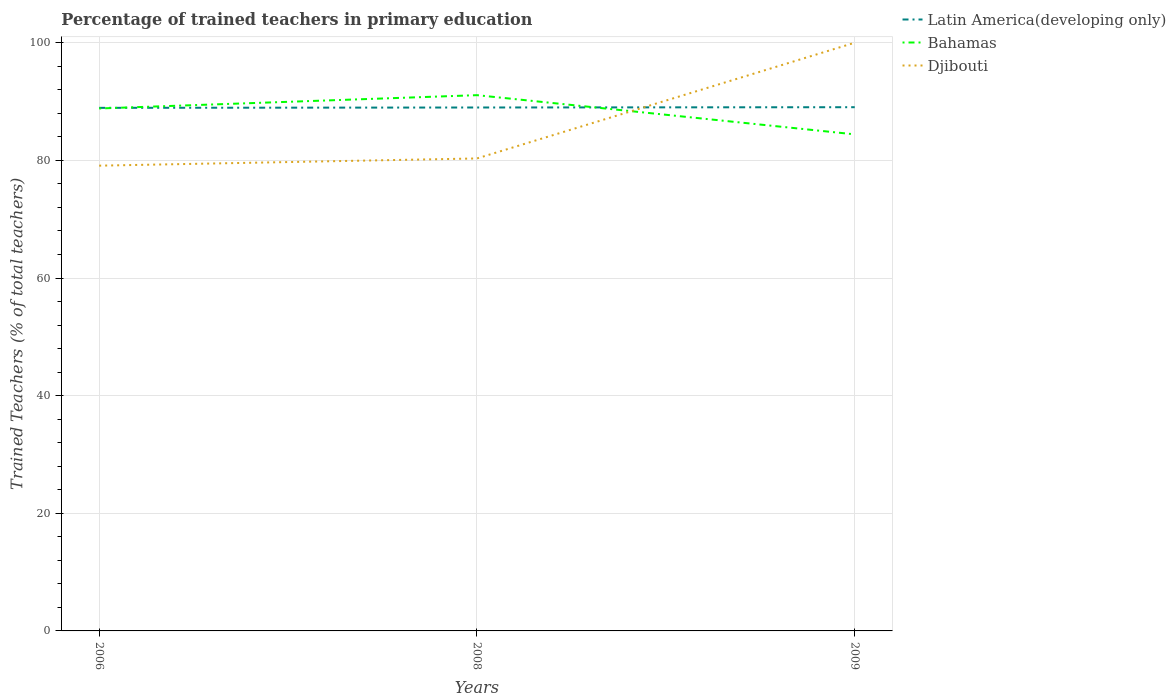How many different coloured lines are there?
Give a very brief answer. 3. Does the line corresponding to Djibouti intersect with the line corresponding to Latin America(developing only)?
Your answer should be very brief. Yes. Across all years, what is the maximum percentage of trained teachers in Latin America(developing only)?
Give a very brief answer. 88.93. In which year was the percentage of trained teachers in Bahamas maximum?
Provide a short and direct response. 2009. What is the total percentage of trained teachers in Bahamas in the graph?
Ensure brevity in your answer.  6.66. What is the difference between the highest and the second highest percentage of trained teachers in Bahamas?
Provide a succinct answer. 6.66. What is the difference between the highest and the lowest percentage of trained teachers in Latin America(developing only)?
Your answer should be compact. 2. Is the percentage of trained teachers in Latin America(developing only) strictly greater than the percentage of trained teachers in Djibouti over the years?
Provide a succinct answer. No. What is the difference between two consecutive major ticks on the Y-axis?
Make the answer very short. 20. How many legend labels are there?
Keep it short and to the point. 3. What is the title of the graph?
Keep it short and to the point. Percentage of trained teachers in primary education. Does "Burundi" appear as one of the legend labels in the graph?
Keep it short and to the point. No. What is the label or title of the Y-axis?
Ensure brevity in your answer.  Trained Teachers (% of total teachers). What is the Trained Teachers (% of total teachers) in Latin America(developing only) in 2006?
Provide a succinct answer. 88.93. What is the Trained Teachers (% of total teachers) in Bahamas in 2006?
Provide a short and direct response. 88.82. What is the Trained Teachers (% of total teachers) in Djibouti in 2006?
Offer a very short reply. 79.1. What is the Trained Teachers (% of total teachers) in Latin America(developing only) in 2008?
Your answer should be compact. 88.99. What is the Trained Teachers (% of total teachers) of Bahamas in 2008?
Provide a succinct answer. 91.08. What is the Trained Teachers (% of total teachers) of Djibouti in 2008?
Provide a short and direct response. 80.33. What is the Trained Teachers (% of total teachers) in Latin America(developing only) in 2009?
Keep it short and to the point. 89.04. What is the Trained Teachers (% of total teachers) of Bahamas in 2009?
Your response must be concise. 84.42. Across all years, what is the maximum Trained Teachers (% of total teachers) in Latin America(developing only)?
Your answer should be compact. 89.04. Across all years, what is the maximum Trained Teachers (% of total teachers) in Bahamas?
Your answer should be compact. 91.08. Across all years, what is the maximum Trained Teachers (% of total teachers) of Djibouti?
Your answer should be very brief. 100. Across all years, what is the minimum Trained Teachers (% of total teachers) in Latin America(developing only)?
Your answer should be very brief. 88.93. Across all years, what is the minimum Trained Teachers (% of total teachers) in Bahamas?
Give a very brief answer. 84.42. Across all years, what is the minimum Trained Teachers (% of total teachers) in Djibouti?
Ensure brevity in your answer.  79.1. What is the total Trained Teachers (% of total teachers) in Latin America(developing only) in the graph?
Your response must be concise. 266.95. What is the total Trained Teachers (% of total teachers) of Bahamas in the graph?
Offer a very short reply. 264.33. What is the total Trained Teachers (% of total teachers) of Djibouti in the graph?
Your answer should be very brief. 259.42. What is the difference between the Trained Teachers (% of total teachers) of Latin America(developing only) in 2006 and that in 2008?
Your answer should be very brief. -0.06. What is the difference between the Trained Teachers (% of total teachers) in Bahamas in 2006 and that in 2008?
Give a very brief answer. -2.26. What is the difference between the Trained Teachers (% of total teachers) in Djibouti in 2006 and that in 2008?
Your response must be concise. -1.23. What is the difference between the Trained Teachers (% of total teachers) of Latin America(developing only) in 2006 and that in 2009?
Make the answer very short. -0.11. What is the difference between the Trained Teachers (% of total teachers) of Bahamas in 2006 and that in 2009?
Ensure brevity in your answer.  4.4. What is the difference between the Trained Teachers (% of total teachers) in Djibouti in 2006 and that in 2009?
Provide a short and direct response. -20.9. What is the difference between the Trained Teachers (% of total teachers) in Latin America(developing only) in 2008 and that in 2009?
Provide a succinct answer. -0.05. What is the difference between the Trained Teachers (% of total teachers) in Bahamas in 2008 and that in 2009?
Offer a very short reply. 6.66. What is the difference between the Trained Teachers (% of total teachers) of Djibouti in 2008 and that in 2009?
Make the answer very short. -19.67. What is the difference between the Trained Teachers (% of total teachers) of Latin America(developing only) in 2006 and the Trained Teachers (% of total teachers) of Bahamas in 2008?
Give a very brief answer. -2.16. What is the difference between the Trained Teachers (% of total teachers) in Latin America(developing only) in 2006 and the Trained Teachers (% of total teachers) in Djibouti in 2008?
Give a very brief answer. 8.6. What is the difference between the Trained Teachers (% of total teachers) of Bahamas in 2006 and the Trained Teachers (% of total teachers) of Djibouti in 2008?
Keep it short and to the point. 8.5. What is the difference between the Trained Teachers (% of total teachers) in Latin America(developing only) in 2006 and the Trained Teachers (% of total teachers) in Bahamas in 2009?
Offer a terse response. 4.51. What is the difference between the Trained Teachers (% of total teachers) of Latin America(developing only) in 2006 and the Trained Teachers (% of total teachers) of Djibouti in 2009?
Your answer should be very brief. -11.07. What is the difference between the Trained Teachers (% of total teachers) in Bahamas in 2006 and the Trained Teachers (% of total teachers) in Djibouti in 2009?
Offer a very short reply. -11.18. What is the difference between the Trained Teachers (% of total teachers) in Latin America(developing only) in 2008 and the Trained Teachers (% of total teachers) in Bahamas in 2009?
Your answer should be compact. 4.57. What is the difference between the Trained Teachers (% of total teachers) in Latin America(developing only) in 2008 and the Trained Teachers (% of total teachers) in Djibouti in 2009?
Provide a short and direct response. -11.01. What is the difference between the Trained Teachers (% of total teachers) in Bahamas in 2008 and the Trained Teachers (% of total teachers) in Djibouti in 2009?
Offer a terse response. -8.92. What is the average Trained Teachers (% of total teachers) in Latin America(developing only) per year?
Your answer should be very brief. 88.98. What is the average Trained Teachers (% of total teachers) of Bahamas per year?
Give a very brief answer. 88.11. What is the average Trained Teachers (% of total teachers) of Djibouti per year?
Your answer should be compact. 86.47. In the year 2006, what is the difference between the Trained Teachers (% of total teachers) of Latin America(developing only) and Trained Teachers (% of total teachers) of Bahamas?
Provide a succinct answer. 0.11. In the year 2006, what is the difference between the Trained Teachers (% of total teachers) of Latin America(developing only) and Trained Teachers (% of total teachers) of Djibouti?
Offer a terse response. 9.83. In the year 2006, what is the difference between the Trained Teachers (% of total teachers) of Bahamas and Trained Teachers (% of total teachers) of Djibouti?
Your answer should be very brief. 9.72. In the year 2008, what is the difference between the Trained Teachers (% of total teachers) of Latin America(developing only) and Trained Teachers (% of total teachers) of Bahamas?
Your answer should be very brief. -2.1. In the year 2008, what is the difference between the Trained Teachers (% of total teachers) of Latin America(developing only) and Trained Teachers (% of total teachers) of Djibouti?
Make the answer very short. 8.66. In the year 2008, what is the difference between the Trained Teachers (% of total teachers) of Bahamas and Trained Teachers (% of total teachers) of Djibouti?
Provide a succinct answer. 10.76. In the year 2009, what is the difference between the Trained Teachers (% of total teachers) of Latin America(developing only) and Trained Teachers (% of total teachers) of Bahamas?
Provide a succinct answer. 4.62. In the year 2009, what is the difference between the Trained Teachers (% of total teachers) in Latin America(developing only) and Trained Teachers (% of total teachers) in Djibouti?
Provide a short and direct response. -10.96. In the year 2009, what is the difference between the Trained Teachers (% of total teachers) of Bahamas and Trained Teachers (% of total teachers) of Djibouti?
Provide a short and direct response. -15.58. What is the ratio of the Trained Teachers (% of total teachers) in Latin America(developing only) in 2006 to that in 2008?
Ensure brevity in your answer.  1. What is the ratio of the Trained Teachers (% of total teachers) in Bahamas in 2006 to that in 2008?
Provide a short and direct response. 0.98. What is the ratio of the Trained Teachers (% of total teachers) in Djibouti in 2006 to that in 2008?
Ensure brevity in your answer.  0.98. What is the ratio of the Trained Teachers (% of total teachers) of Bahamas in 2006 to that in 2009?
Your response must be concise. 1.05. What is the ratio of the Trained Teachers (% of total teachers) in Djibouti in 2006 to that in 2009?
Offer a terse response. 0.79. What is the ratio of the Trained Teachers (% of total teachers) in Latin America(developing only) in 2008 to that in 2009?
Offer a very short reply. 1. What is the ratio of the Trained Teachers (% of total teachers) of Bahamas in 2008 to that in 2009?
Your answer should be very brief. 1.08. What is the ratio of the Trained Teachers (% of total teachers) of Djibouti in 2008 to that in 2009?
Your answer should be very brief. 0.8. What is the difference between the highest and the second highest Trained Teachers (% of total teachers) of Latin America(developing only)?
Offer a terse response. 0.05. What is the difference between the highest and the second highest Trained Teachers (% of total teachers) in Bahamas?
Keep it short and to the point. 2.26. What is the difference between the highest and the second highest Trained Teachers (% of total teachers) in Djibouti?
Your response must be concise. 19.67. What is the difference between the highest and the lowest Trained Teachers (% of total teachers) of Latin America(developing only)?
Offer a very short reply. 0.11. What is the difference between the highest and the lowest Trained Teachers (% of total teachers) of Bahamas?
Provide a succinct answer. 6.66. What is the difference between the highest and the lowest Trained Teachers (% of total teachers) of Djibouti?
Offer a very short reply. 20.9. 